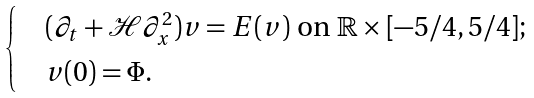<formula> <loc_0><loc_0><loc_500><loc_500>\begin{cases} & ( \partial _ { t } + \mathcal { H } \partial _ { x } ^ { 2 } ) v = E ( v ) \text { on } \mathbb { R } \times [ - 5 / 4 , 5 / 4 ] ; \\ & v ( 0 ) = \Phi . \end{cases}</formula> 